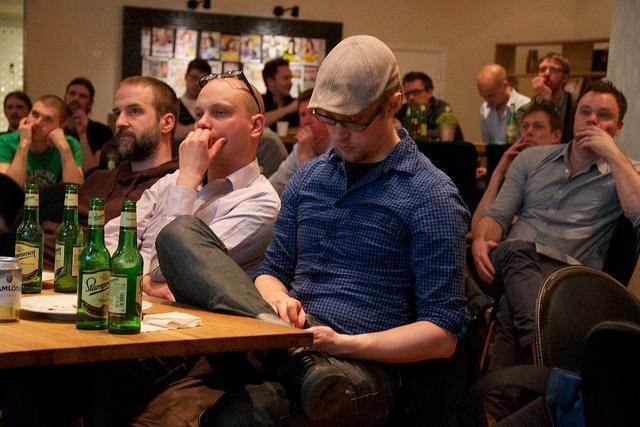How many guys are in the image?
Give a very brief answer. 14. How many chairs are there?
Give a very brief answer. 3. How many bottles are there?
Give a very brief answer. 3. How many people are in the picture?
Give a very brief answer. 12. 